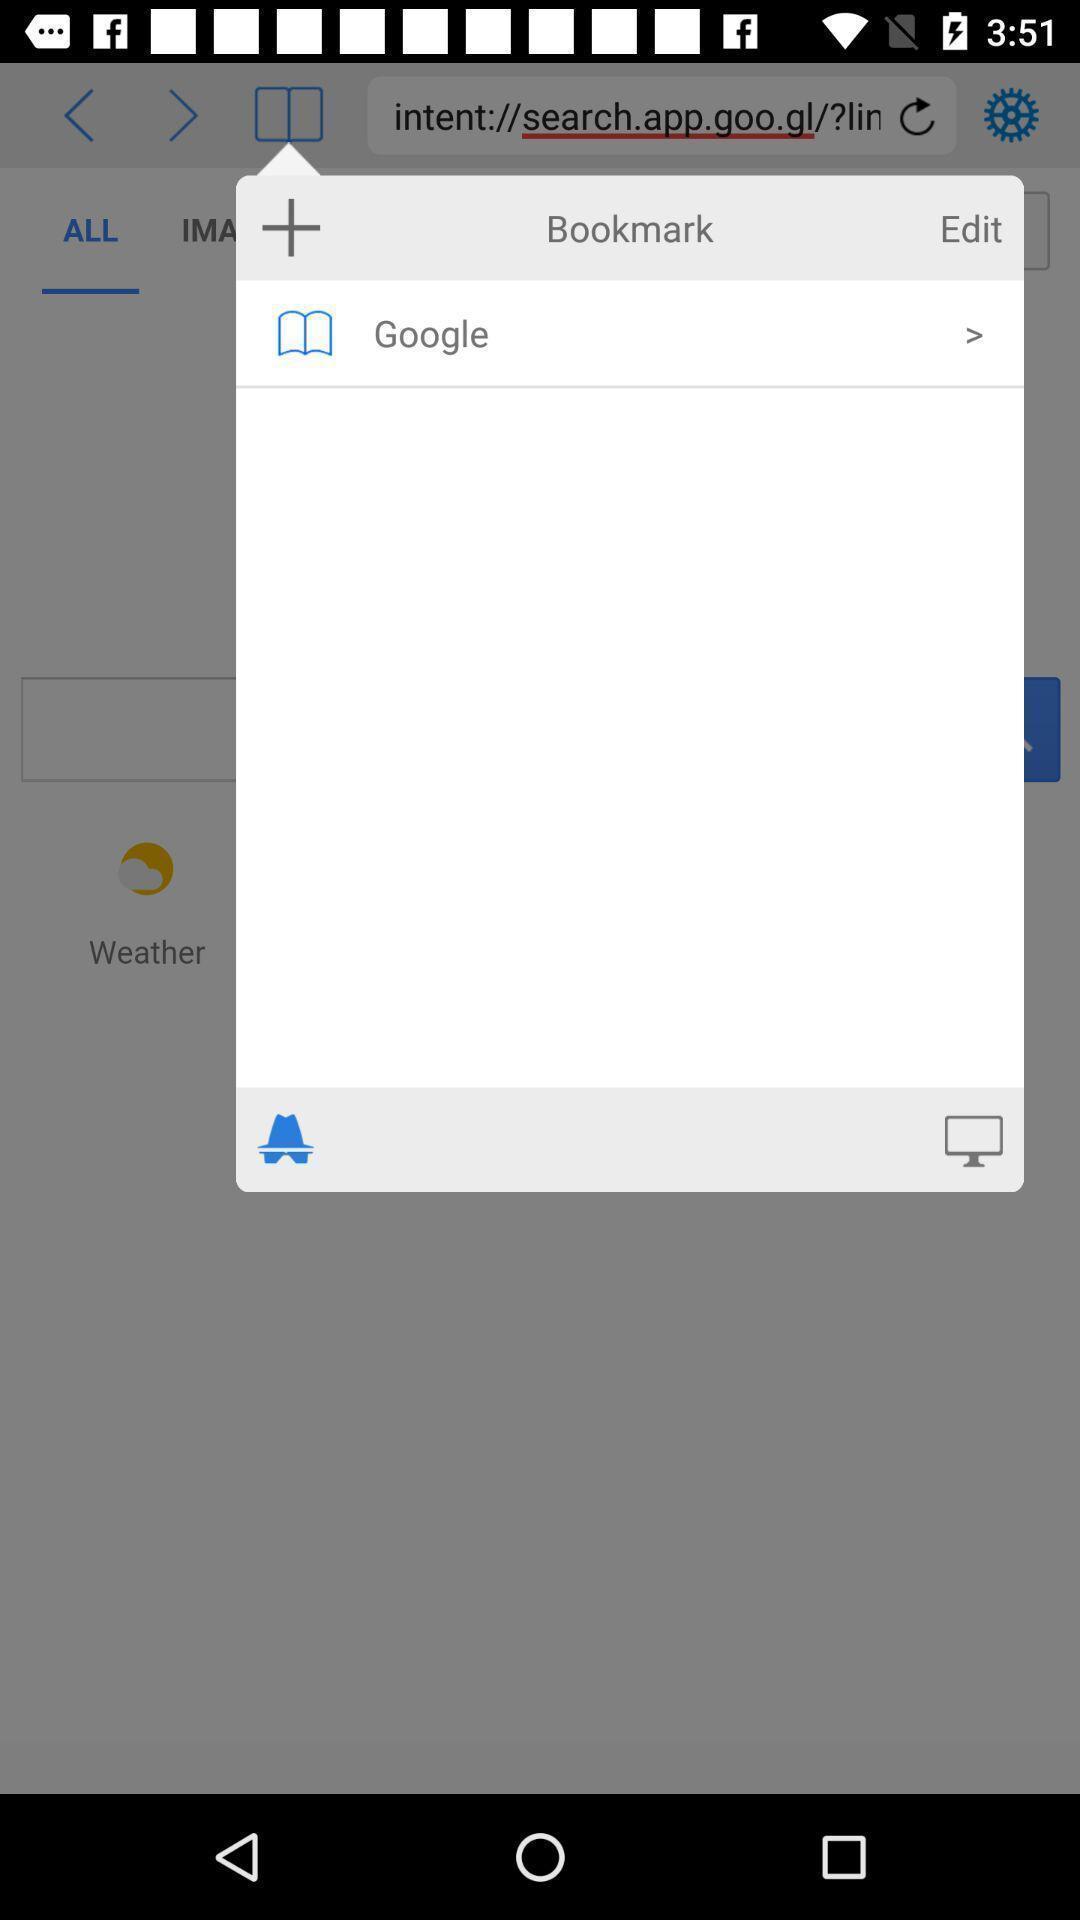Provide a description of this screenshot. Pop-up shows to add bookmark of this website. 